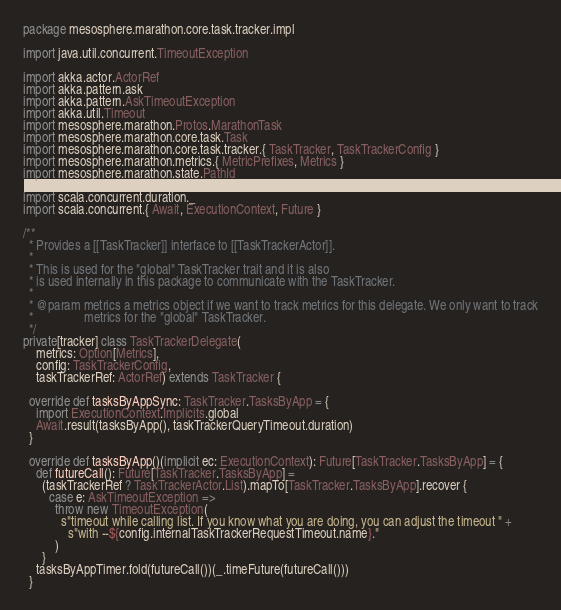<code> <loc_0><loc_0><loc_500><loc_500><_Scala_>package mesosphere.marathon.core.task.tracker.impl

import java.util.concurrent.TimeoutException

import akka.actor.ActorRef
import akka.pattern.ask
import akka.pattern.AskTimeoutException
import akka.util.Timeout
import mesosphere.marathon.Protos.MarathonTask
import mesosphere.marathon.core.task.Task
import mesosphere.marathon.core.task.tracker.{ TaskTracker, TaskTrackerConfig }
import mesosphere.marathon.metrics.{ MetricPrefixes, Metrics }
import mesosphere.marathon.state.PathId

import scala.concurrent.duration._
import scala.concurrent.{ Await, ExecutionContext, Future }

/**
  * Provides a [[TaskTracker]] interface to [[TaskTrackerActor]].
  *
  * This is used for the "global" TaskTracker trait and it is also
  * is used internally in this package to communicate with the TaskTracker.
  *
  * @param metrics a metrics object if we want to track metrics for this delegate. We only want to track
  *                metrics for the "global" TaskTracker.
  */
private[tracker] class TaskTrackerDelegate(
    metrics: Option[Metrics],
    config: TaskTrackerConfig,
    taskTrackerRef: ActorRef) extends TaskTracker {

  override def tasksByAppSync: TaskTracker.TasksByApp = {
    import ExecutionContext.Implicits.global
    Await.result(tasksByApp(), taskTrackerQueryTimeout.duration)
  }

  override def tasksByApp()(implicit ec: ExecutionContext): Future[TaskTracker.TasksByApp] = {
    def futureCall(): Future[TaskTracker.TasksByApp] =
      (taskTrackerRef ? TaskTrackerActor.List).mapTo[TaskTracker.TasksByApp].recover {
        case e: AskTimeoutException =>
          throw new TimeoutException(
            s"timeout while calling list. If you know what you are doing, you can adjust the timeout " +
              s"with --${config.internalTaskTrackerRequestTimeout.name}."
          )
      }
    tasksByAppTimer.fold(futureCall())(_.timeFuture(futureCall()))
  }
</code> 